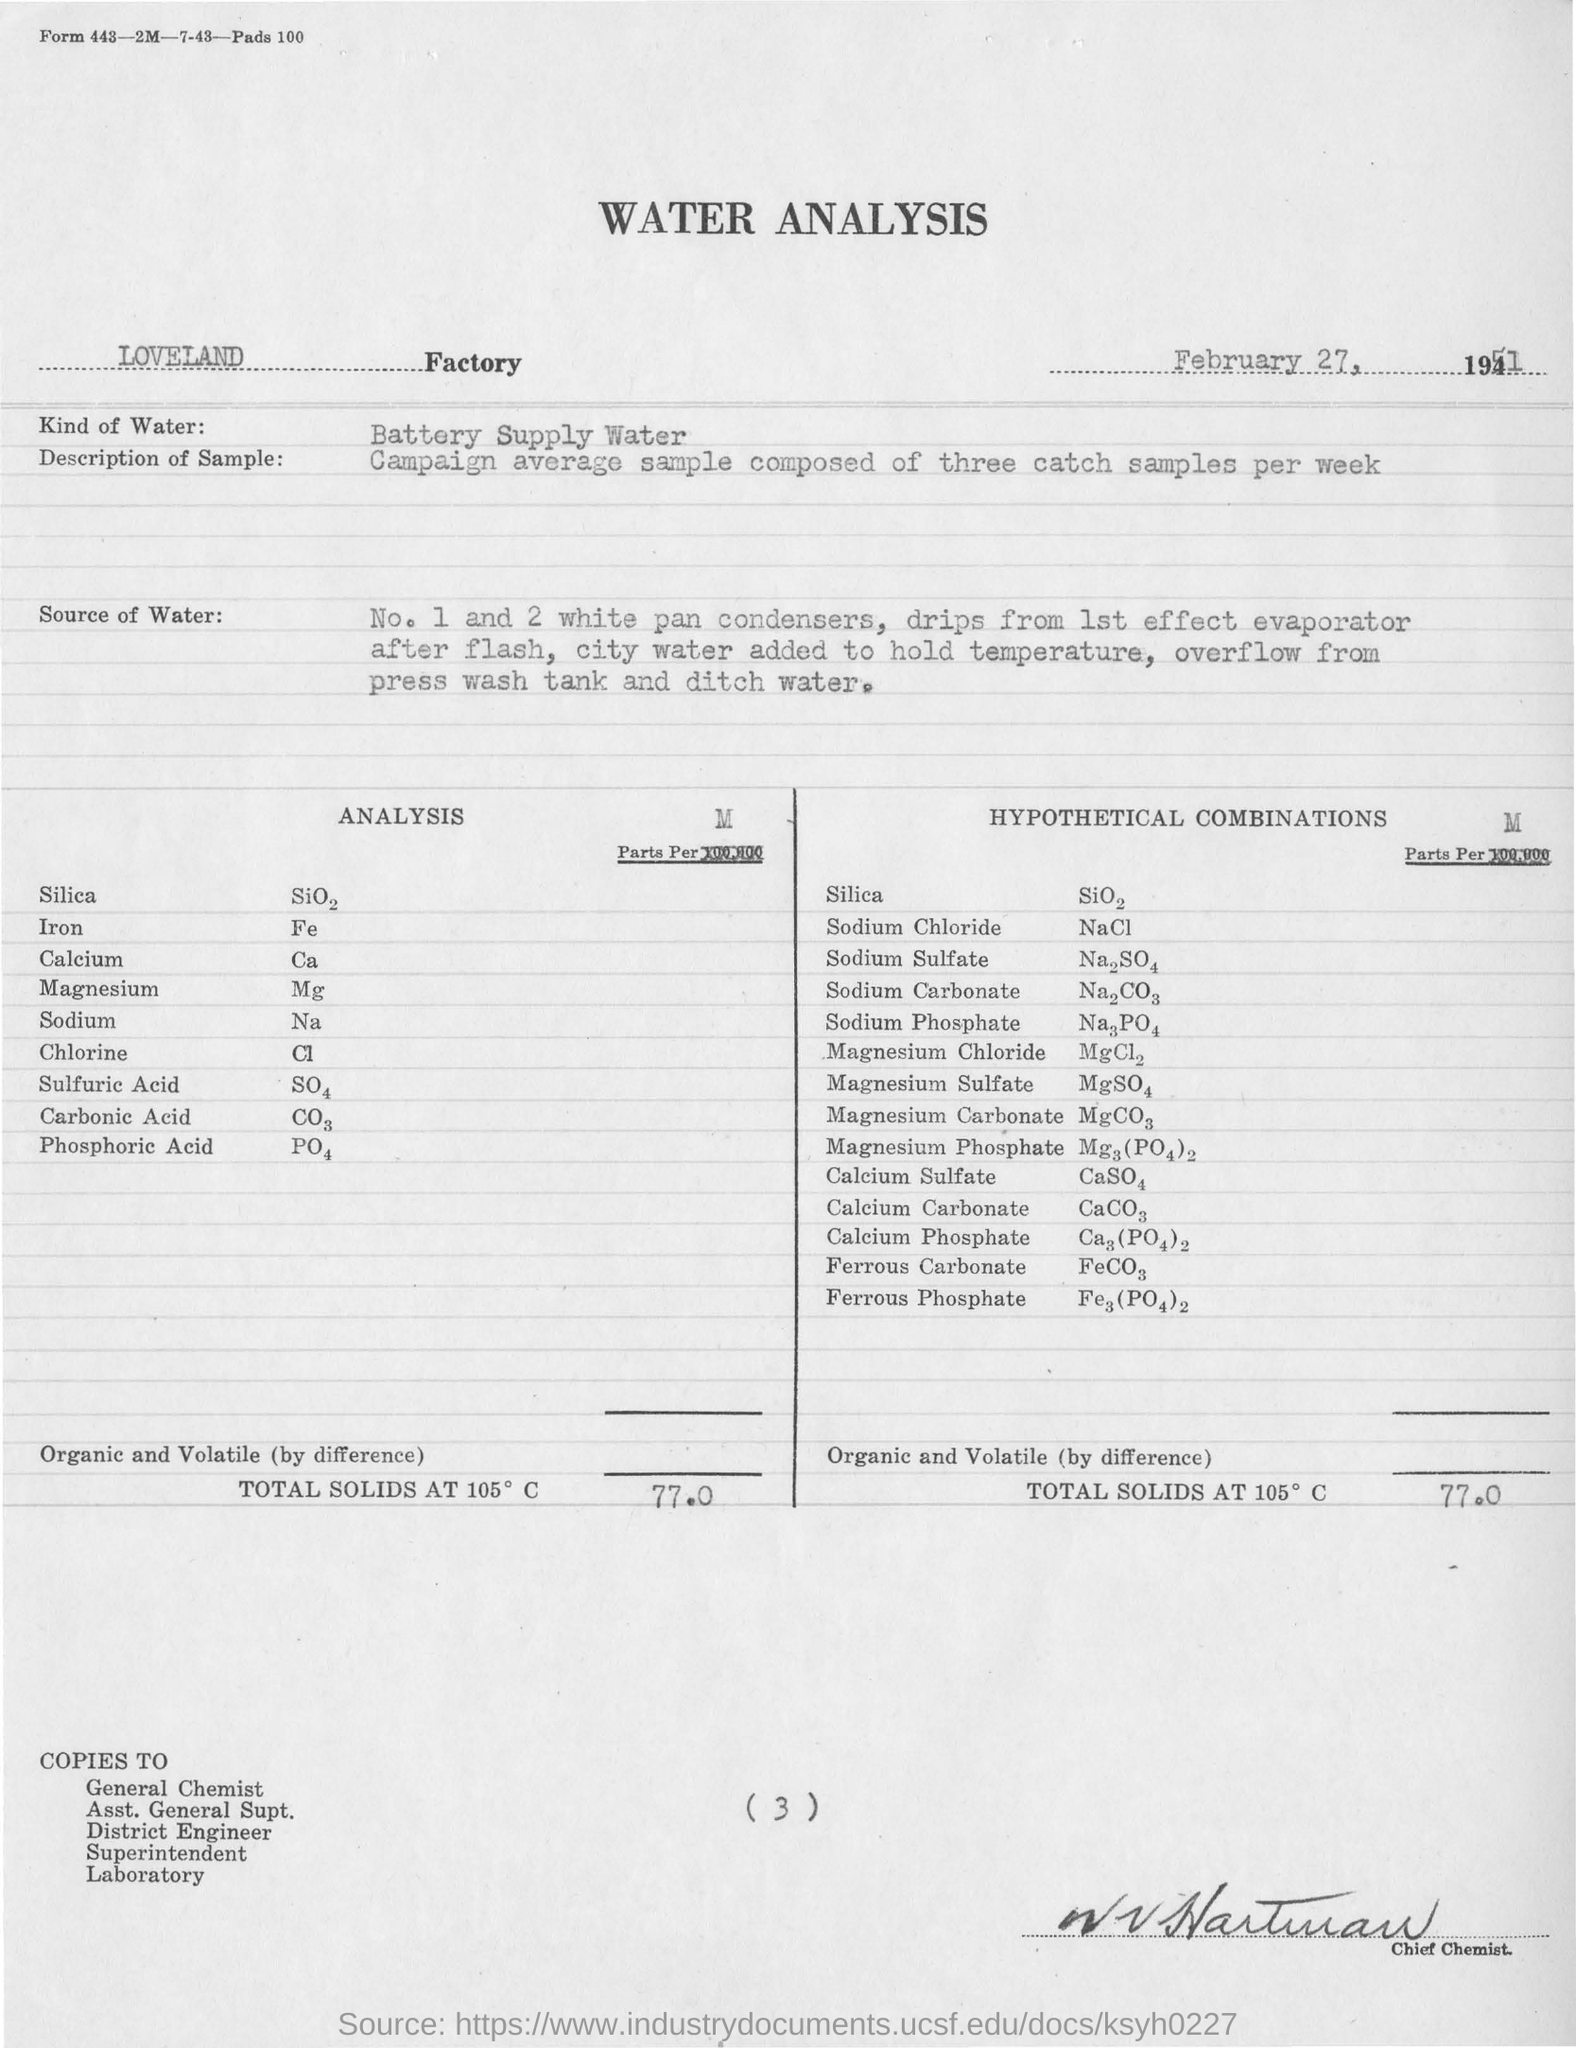Which factory has done the analysis?
Keep it short and to the point. LOVELAND Factory. How mush is the TOTAL SOLIDS?
Offer a very short reply. 77.0. 